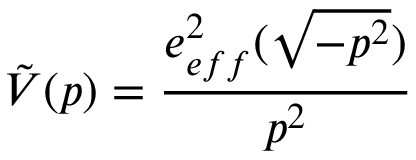<formula> <loc_0><loc_0><loc_500><loc_500>\tilde { V } ( p ) = \frac { e _ { e f f } ^ { 2 } ( \sqrt { - p ^ { 2 } } ) } { p ^ { 2 } }</formula> 